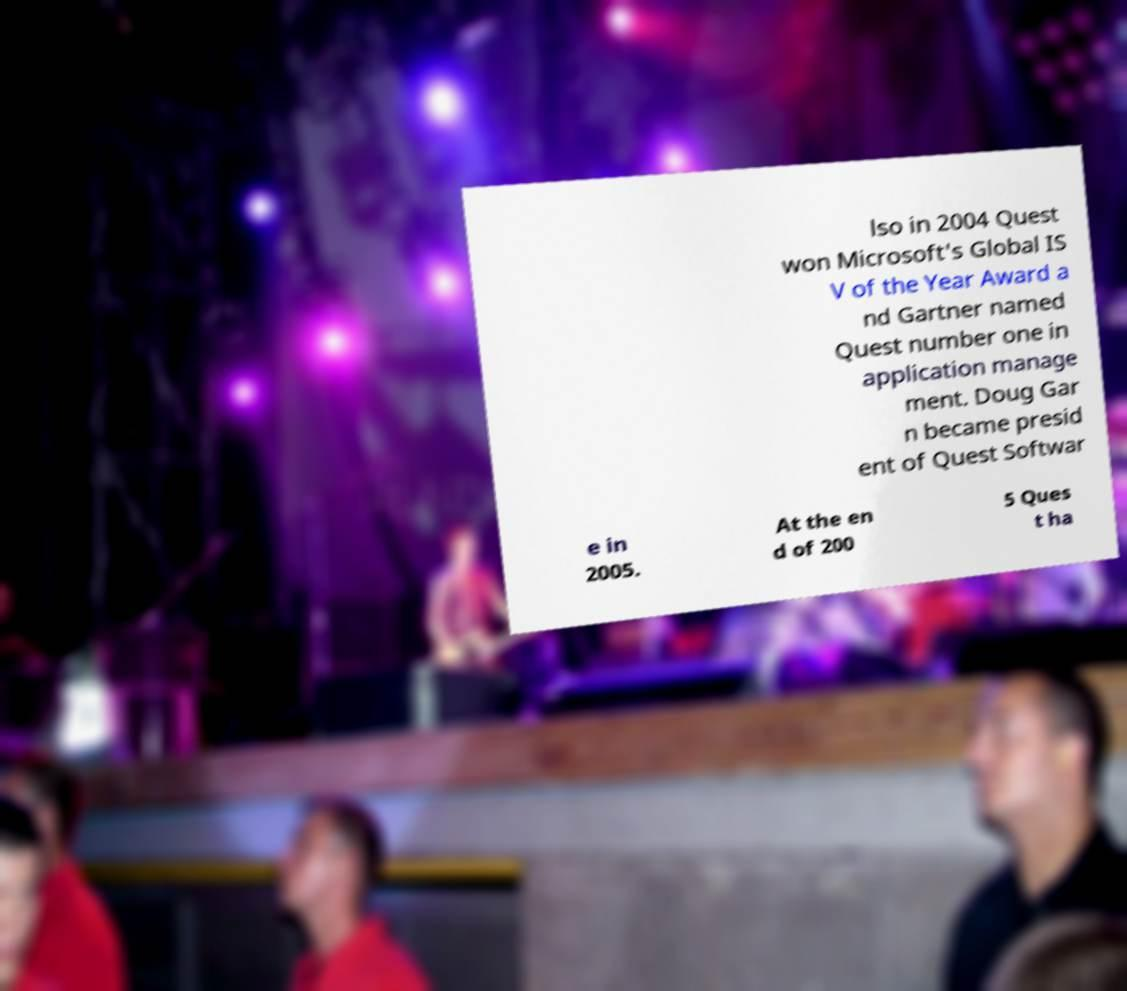Can you accurately transcribe the text from the provided image for me? lso in 2004 Quest won Microsoft's Global IS V of the Year Award a nd Gartner named Quest number one in application manage ment. Doug Gar n became presid ent of Quest Softwar e in 2005. At the en d of 200 5 Ques t ha 